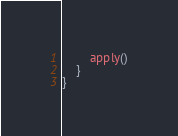<code> <loc_0><loc_0><loc_500><loc_500><_Kotlin_>        apply()
    }
}
</code> 